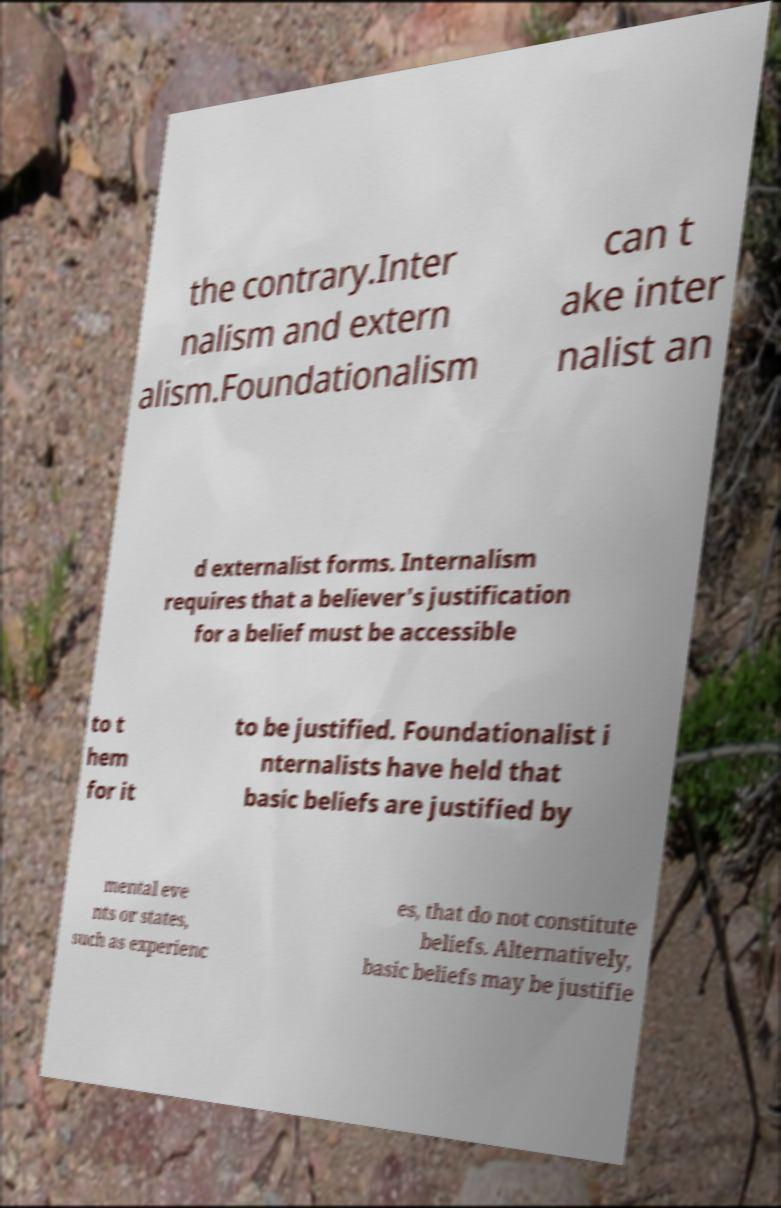Please identify and transcribe the text found in this image. the contrary.Inter nalism and extern alism.Foundationalism can t ake inter nalist an d externalist forms. Internalism requires that a believer's justification for a belief must be accessible to t hem for it to be justified. Foundationalist i nternalists have held that basic beliefs are justified by mental eve nts or states, such as experienc es, that do not constitute beliefs. Alternatively, basic beliefs may be justifie 